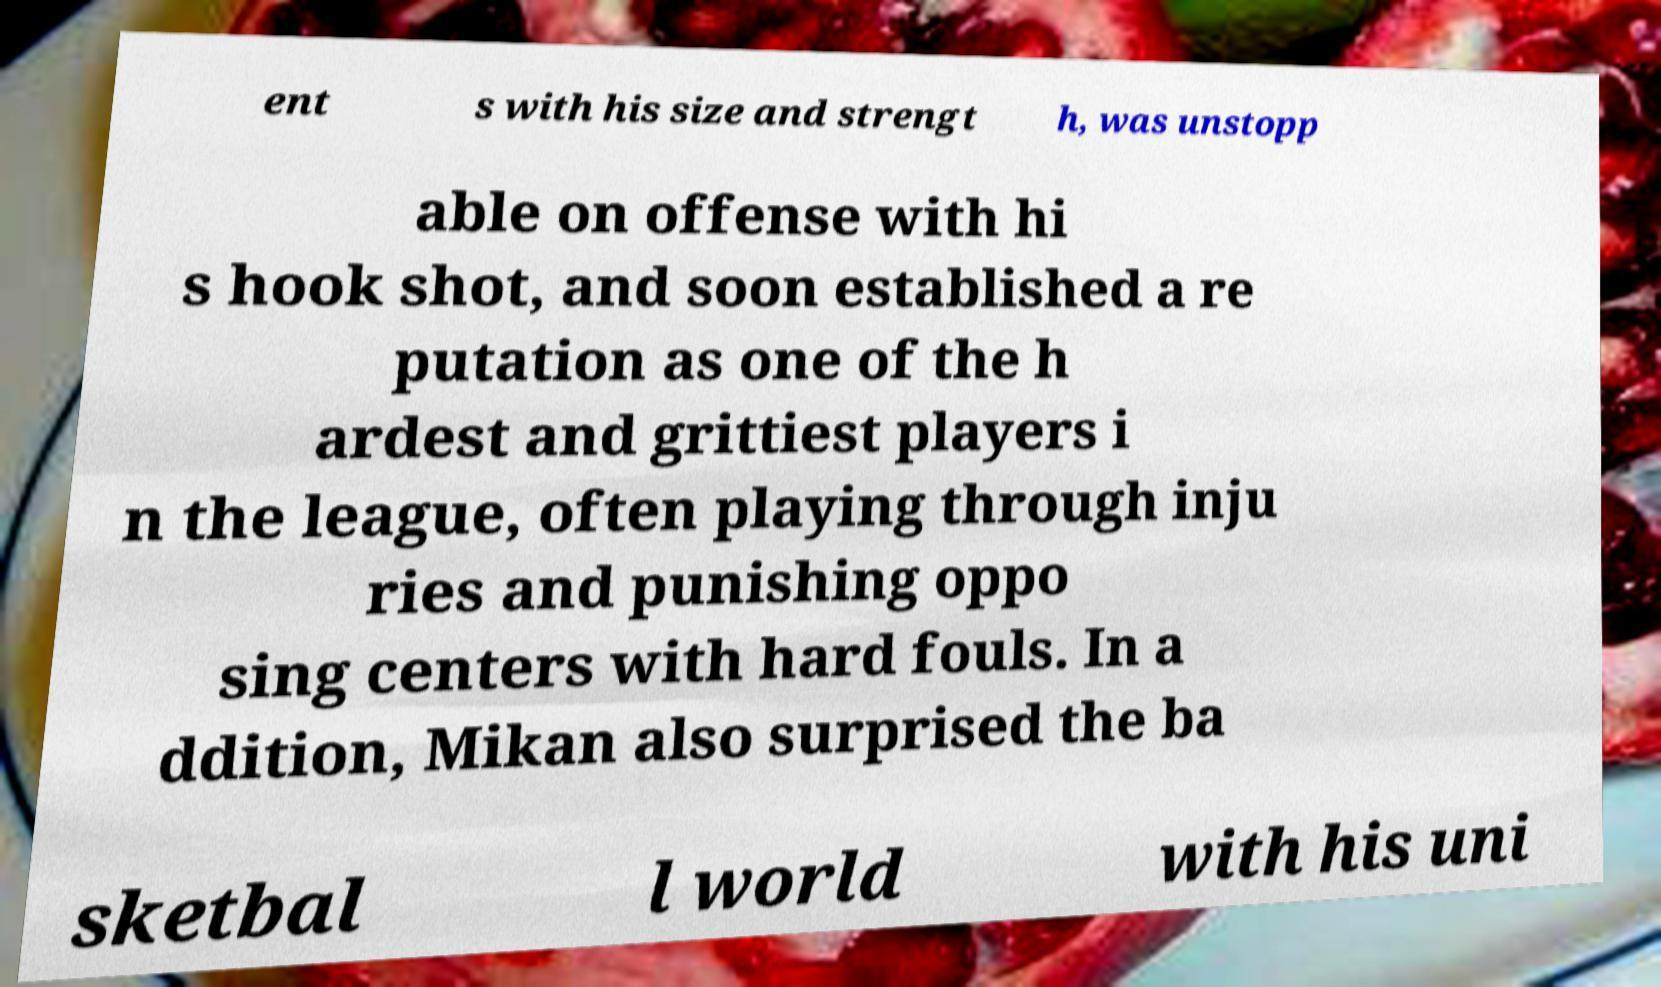There's text embedded in this image that I need extracted. Can you transcribe it verbatim? ent s with his size and strengt h, was unstopp able on offense with hi s hook shot, and soon established a re putation as one of the h ardest and grittiest players i n the league, often playing through inju ries and punishing oppo sing centers with hard fouls. In a ddition, Mikan also surprised the ba sketbal l world with his uni 